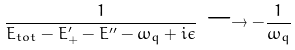<formula> <loc_0><loc_0><loc_500><loc_500>\frac { 1 } { E _ { t o t } - E _ { + } ^ { \prime } - E ^ { \prime \prime } - \omega _ { q } + i \epsilon } \, \longrightarrow - \frac { 1 } { \omega _ { q } }</formula> 